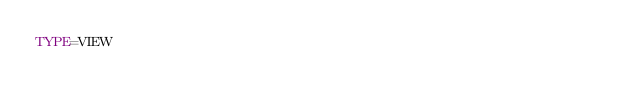Convert code to text. <code><loc_0><loc_0><loc_500><loc_500><_VisualBasic_>TYPE=VIEW</code> 